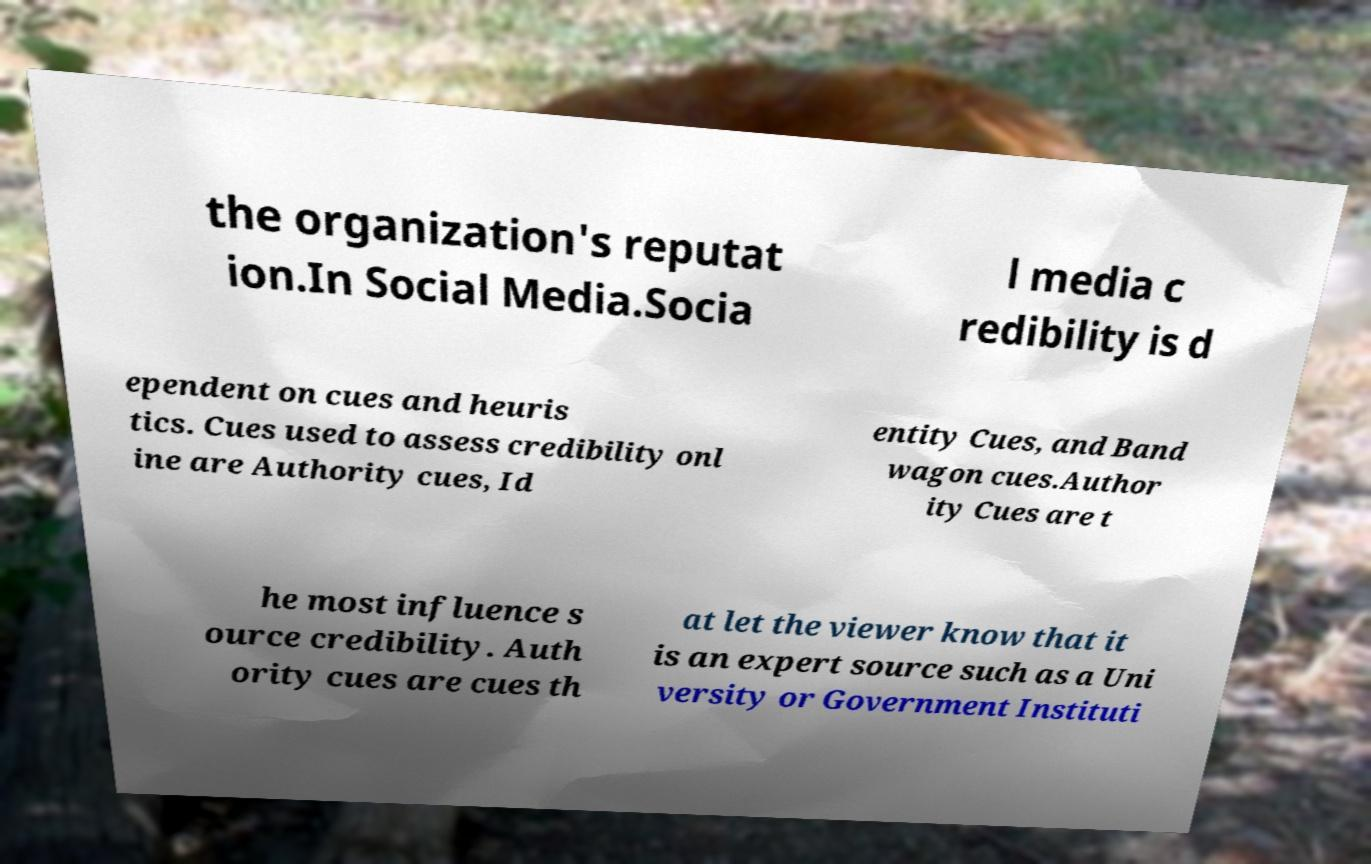Can you read and provide the text displayed in the image?This photo seems to have some interesting text. Can you extract and type it out for me? the organization's reputat ion.In Social Media.Socia l media c redibility is d ependent on cues and heuris tics. Cues used to assess credibility onl ine are Authority cues, Id entity Cues, and Band wagon cues.Author ity Cues are t he most influence s ource credibility. Auth ority cues are cues th at let the viewer know that it is an expert source such as a Uni versity or Government Instituti 